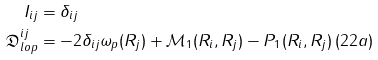Convert formula to latex. <formula><loc_0><loc_0><loc_500><loc_500>I _ { i j } & = \delta _ { i j } \\ \mathfrak { D } _ { l o p } ^ { i j } & = - 2 \delta _ { i j } \omega _ { p } ( R _ { j } ) + \mathcal { M } _ { 1 } ( R _ { i } , R _ { j } ) - P _ { 1 } ( R _ { i } , R _ { j } ) \, ( 2 2 a ) \\</formula> 